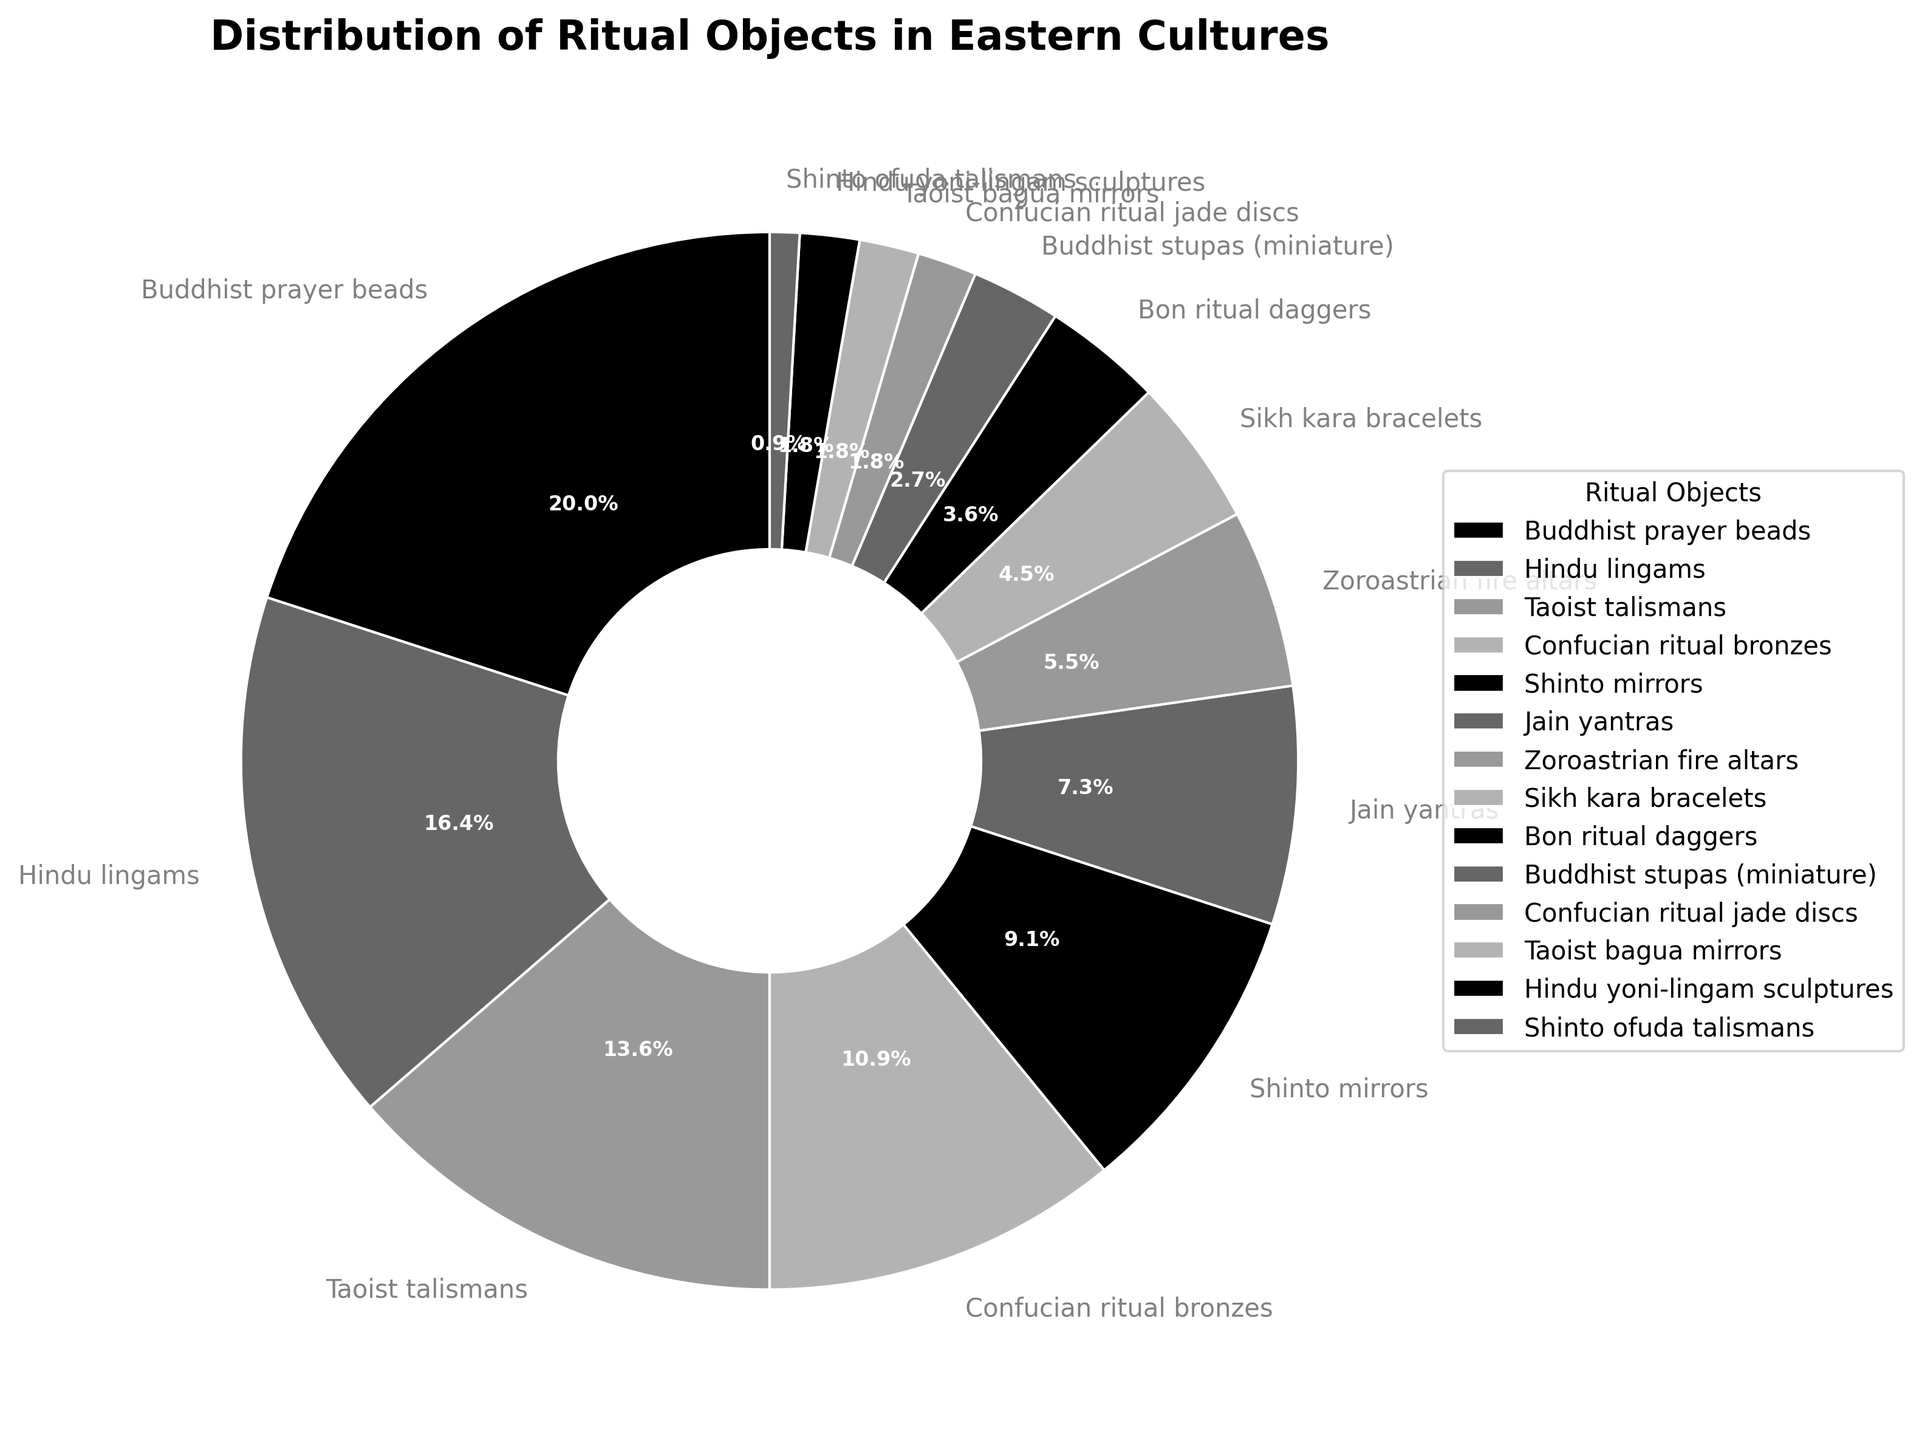What are the top three categories of ritual objects by percentage? To answer this question, look at the pie chart and identify the three largest wedges. They represent the largest percentages. They are Buddhist prayer beads (22%), Hindu lingams (18%), and Taoist talismans (15%).
Answer: Buddhist prayer beads, Hindu lingams, Taoist talismans Which category has the smallest representation in the pie chart? Examine all the slices in the pie chart and find the smallest one. The smallest slice is Shinto ofuda talismans with 1%.
Answer: Shinto ofuda talismans What is the combined percentage of Buddhist prayer beads, Hindu lingams, and Taoist talismans? To find this, add the percentages of these three categories: 22% (Buddhist prayer beads) + 18% (Hindu lingams) + 15% (Taoist talismans) = 55%.
Answer: 55% How much more prevalent are Buddhist prayer beads compared to Shinto mirrors? Subtract the percentage of Shinto mirrors from the percentage of Buddhist prayer beads: 22% (Buddhist prayer beads) - 10% (Shinto mirrors) = 12%.
Answer: 12% If we grouped the three least common categories together, what would their combined percentage be? Add the percentages of the three smallest categories: Shinto ofuda talismans (1%), Confucian ritual jade discs (2%), and Taoist bagua mirrors (2%). Their combined percentage is 1% + 2% + 2% = 5%.
Answer: 5% Do the combined percentages of Jain yantras and Zoroastrian fire altars exceed that of Hindu lingams? Add the percentages of Jain yantras (8%) and Zoroastrian fire altars (6%) to see if their total is greater than Hindu lingams (18%): 8% + 6% = 14%, which is less than 18%.
Answer: No Which two categories have equal percentages? Scan the pie chart for any slices with equal percentages. The categories Taoist bagua mirrors and Confucian ritual jade discs both have 2%.
Answer: Taoist bagua mirrors, Confucian ritual jade discs How does the prevalence of Sikh kara bracelets compare to Confucian ritual bronzes? Both percentages are found on the pie chart: Sikh kara bracelets have 5%, and Confucian ritual bronzes have 12%. Confucian ritual bronzes are more prevalent.
Answer: Less prevalent 